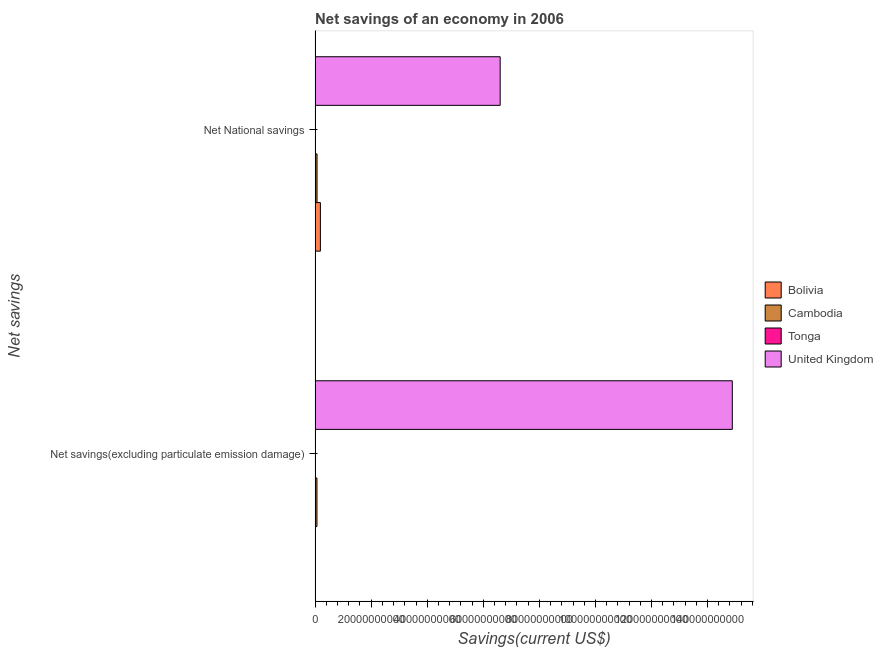How many groups of bars are there?
Make the answer very short. 2. Are the number of bars per tick equal to the number of legend labels?
Provide a succinct answer. Yes. How many bars are there on the 2nd tick from the top?
Ensure brevity in your answer.  4. What is the label of the 2nd group of bars from the top?
Make the answer very short. Net savings(excluding particulate emission damage). What is the net savings(excluding particulate emission damage) in Bolivia?
Offer a very short reply. 1.29e+08. Across all countries, what is the maximum net national savings?
Your response must be concise. 6.60e+1. Across all countries, what is the minimum net savings(excluding particulate emission damage)?
Keep it short and to the point. 2.58e+07. In which country was the net national savings minimum?
Offer a terse response. Tonga. What is the total net national savings in the graph?
Provide a short and direct response. 6.86e+1. What is the difference between the net national savings in Bolivia and that in Cambodia?
Provide a short and direct response. 1.20e+09. What is the difference between the net national savings in Bolivia and the net savings(excluding particulate emission damage) in Tonga?
Offer a very short reply. 1.86e+09. What is the average net national savings per country?
Provide a short and direct response. 1.72e+1. What is the difference between the net savings(excluding particulate emission damage) and net national savings in Tonga?
Keep it short and to the point. 7.23e+06. What is the ratio of the net savings(excluding particulate emission damage) in Tonga to that in Cambodia?
Offer a terse response. 0.04. Is the net savings(excluding particulate emission damage) in Tonga less than that in United Kingdom?
Your answer should be compact. Yes. What does the 2nd bar from the top in Net National savings represents?
Keep it short and to the point. Tonga. How many bars are there?
Your response must be concise. 8. How many countries are there in the graph?
Provide a short and direct response. 4. Are the values on the major ticks of X-axis written in scientific E-notation?
Provide a short and direct response. No. Does the graph contain any zero values?
Provide a short and direct response. No. Does the graph contain grids?
Provide a succinct answer. No. Where does the legend appear in the graph?
Ensure brevity in your answer.  Center right. How many legend labels are there?
Your answer should be very brief. 4. What is the title of the graph?
Your answer should be very brief. Net savings of an economy in 2006. What is the label or title of the X-axis?
Provide a succinct answer. Savings(current US$). What is the label or title of the Y-axis?
Give a very brief answer. Net savings. What is the Savings(current US$) of Bolivia in Net savings(excluding particulate emission damage)?
Keep it short and to the point. 1.29e+08. What is the Savings(current US$) in Cambodia in Net savings(excluding particulate emission damage)?
Your answer should be compact. 6.58e+08. What is the Savings(current US$) of Tonga in Net savings(excluding particulate emission damage)?
Offer a very short reply. 2.58e+07. What is the Savings(current US$) in United Kingdom in Net savings(excluding particulate emission damage)?
Your answer should be compact. 1.49e+11. What is the Savings(current US$) in Bolivia in Net National savings?
Your answer should be very brief. 1.88e+09. What is the Savings(current US$) of Cambodia in Net National savings?
Your answer should be compact. 6.89e+08. What is the Savings(current US$) of Tonga in Net National savings?
Ensure brevity in your answer.  1.85e+07. What is the Savings(current US$) in United Kingdom in Net National savings?
Give a very brief answer. 6.60e+1. Across all Net savings, what is the maximum Savings(current US$) of Bolivia?
Your answer should be compact. 1.88e+09. Across all Net savings, what is the maximum Savings(current US$) of Cambodia?
Your response must be concise. 6.89e+08. Across all Net savings, what is the maximum Savings(current US$) of Tonga?
Your answer should be very brief. 2.58e+07. Across all Net savings, what is the maximum Savings(current US$) of United Kingdom?
Make the answer very short. 1.49e+11. Across all Net savings, what is the minimum Savings(current US$) in Bolivia?
Provide a short and direct response. 1.29e+08. Across all Net savings, what is the minimum Savings(current US$) in Cambodia?
Your answer should be very brief. 6.58e+08. Across all Net savings, what is the minimum Savings(current US$) in Tonga?
Keep it short and to the point. 1.85e+07. Across all Net savings, what is the minimum Savings(current US$) in United Kingdom?
Offer a terse response. 6.60e+1. What is the total Savings(current US$) in Bolivia in the graph?
Keep it short and to the point. 2.01e+09. What is the total Savings(current US$) of Cambodia in the graph?
Your response must be concise. 1.35e+09. What is the total Savings(current US$) in Tonga in the graph?
Offer a very short reply. 4.43e+07. What is the total Savings(current US$) in United Kingdom in the graph?
Your answer should be compact. 2.15e+11. What is the difference between the Savings(current US$) in Bolivia in Net savings(excluding particulate emission damage) and that in Net National savings?
Your answer should be very brief. -1.76e+09. What is the difference between the Savings(current US$) of Cambodia in Net savings(excluding particulate emission damage) and that in Net National savings?
Ensure brevity in your answer.  -3.04e+07. What is the difference between the Savings(current US$) in Tonga in Net savings(excluding particulate emission damage) and that in Net National savings?
Offer a very short reply. 7.23e+06. What is the difference between the Savings(current US$) in United Kingdom in Net savings(excluding particulate emission damage) and that in Net National savings?
Provide a short and direct response. 8.28e+1. What is the difference between the Savings(current US$) in Bolivia in Net savings(excluding particulate emission damage) and the Savings(current US$) in Cambodia in Net National savings?
Offer a very short reply. -5.60e+08. What is the difference between the Savings(current US$) in Bolivia in Net savings(excluding particulate emission damage) and the Savings(current US$) in Tonga in Net National savings?
Give a very brief answer. 1.10e+08. What is the difference between the Savings(current US$) in Bolivia in Net savings(excluding particulate emission damage) and the Savings(current US$) in United Kingdom in Net National savings?
Keep it short and to the point. -6.59e+1. What is the difference between the Savings(current US$) in Cambodia in Net savings(excluding particulate emission damage) and the Savings(current US$) in Tonga in Net National savings?
Provide a succinct answer. 6.40e+08. What is the difference between the Savings(current US$) in Cambodia in Net savings(excluding particulate emission damage) and the Savings(current US$) in United Kingdom in Net National savings?
Give a very brief answer. -6.54e+1. What is the difference between the Savings(current US$) in Tonga in Net savings(excluding particulate emission damage) and the Savings(current US$) in United Kingdom in Net National savings?
Make the answer very short. -6.60e+1. What is the average Savings(current US$) in Bolivia per Net savings?
Your answer should be compact. 1.01e+09. What is the average Savings(current US$) of Cambodia per Net savings?
Your answer should be compact. 6.73e+08. What is the average Savings(current US$) of Tonga per Net savings?
Your answer should be very brief. 2.22e+07. What is the average Savings(current US$) in United Kingdom per Net savings?
Your response must be concise. 1.07e+11. What is the difference between the Savings(current US$) in Bolivia and Savings(current US$) in Cambodia in Net savings(excluding particulate emission damage)?
Ensure brevity in your answer.  -5.29e+08. What is the difference between the Savings(current US$) in Bolivia and Savings(current US$) in Tonga in Net savings(excluding particulate emission damage)?
Make the answer very short. 1.03e+08. What is the difference between the Savings(current US$) in Bolivia and Savings(current US$) in United Kingdom in Net savings(excluding particulate emission damage)?
Your answer should be compact. -1.49e+11. What is the difference between the Savings(current US$) of Cambodia and Savings(current US$) of Tonga in Net savings(excluding particulate emission damage)?
Your answer should be compact. 6.32e+08. What is the difference between the Savings(current US$) in Cambodia and Savings(current US$) in United Kingdom in Net savings(excluding particulate emission damage)?
Your response must be concise. -1.48e+11. What is the difference between the Savings(current US$) in Tonga and Savings(current US$) in United Kingdom in Net savings(excluding particulate emission damage)?
Your answer should be very brief. -1.49e+11. What is the difference between the Savings(current US$) in Bolivia and Savings(current US$) in Cambodia in Net National savings?
Provide a succinct answer. 1.20e+09. What is the difference between the Savings(current US$) in Bolivia and Savings(current US$) in Tonga in Net National savings?
Your answer should be very brief. 1.87e+09. What is the difference between the Savings(current US$) of Bolivia and Savings(current US$) of United Kingdom in Net National savings?
Your answer should be very brief. -6.41e+1. What is the difference between the Savings(current US$) in Cambodia and Savings(current US$) in Tonga in Net National savings?
Make the answer very short. 6.70e+08. What is the difference between the Savings(current US$) of Cambodia and Savings(current US$) of United Kingdom in Net National savings?
Your answer should be compact. -6.53e+1. What is the difference between the Savings(current US$) in Tonga and Savings(current US$) in United Kingdom in Net National savings?
Provide a succinct answer. -6.60e+1. What is the ratio of the Savings(current US$) in Bolivia in Net savings(excluding particulate emission damage) to that in Net National savings?
Ensure brevity in your answer.  0.07. What is the ratio of the Savings(current US$) in Cambodia in Net savings(excluding particulate emission damage) to that in Net National savings?
Give a very brief answer. 0.96. What is the ratio of the Savings(current US$) of Tonga in Net savings(excluding particulate emission damage) to that in Net National savings?
Offer a very short reply. 1.39. What is the ratio of the Savings(current US$) of United Kingdom in Net savings(excluding particulate emission damage) to that in Net National savings?
Make the answer very short. 2.25. What is the difference between the highest and the second highest Savings(current US$) in Bolivia?
Provide a succinct answer. 1.76e+09. What is the difference between the highest and the second highest Savings(current US$) of Cambodia?
Offer a very short reply. 3.04e+07. What is the difference between the highest and the second highest Savings(current US$) in Tonga?
Your answer should be compact. 7.23e+06. What is the difference between the highest and the second highest Savings(current US$) in United Kingdom?
Provide a short and direct response. 8.28e+1. What is the difference between the highest and the lowest Savings(current US$) of Bolivia?
Your answer should be compact. 1.76e+09. What is the difference between the highest and the lowest Savings(current US$) in Cambodia?
Provide a short and direct response. 3.04e+07. What is the difference between the highest and the lowest Savings(current US$) of Tonga?
Give a very brief answer. 7.23e+06. What is the difference between the highest and the lowest Savings(current US$) in United Kingdom?
Offer a terse response. 8.28e+1. 